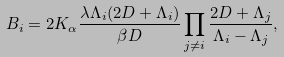<formula> <loc_0><loc_0><loc_500><loc_500>B _ { i } = 2 K _ { \alpha } \frac { \lambda \Lambda _ { i } ( 2 D + \Lambda _ { i } ) } { \beta D } \prod _ { j \neq i } \frac { 2 D + \Lambda _ { j } } { \Lambda _ { i } - \Lambda _ { j } } ,</formula> 